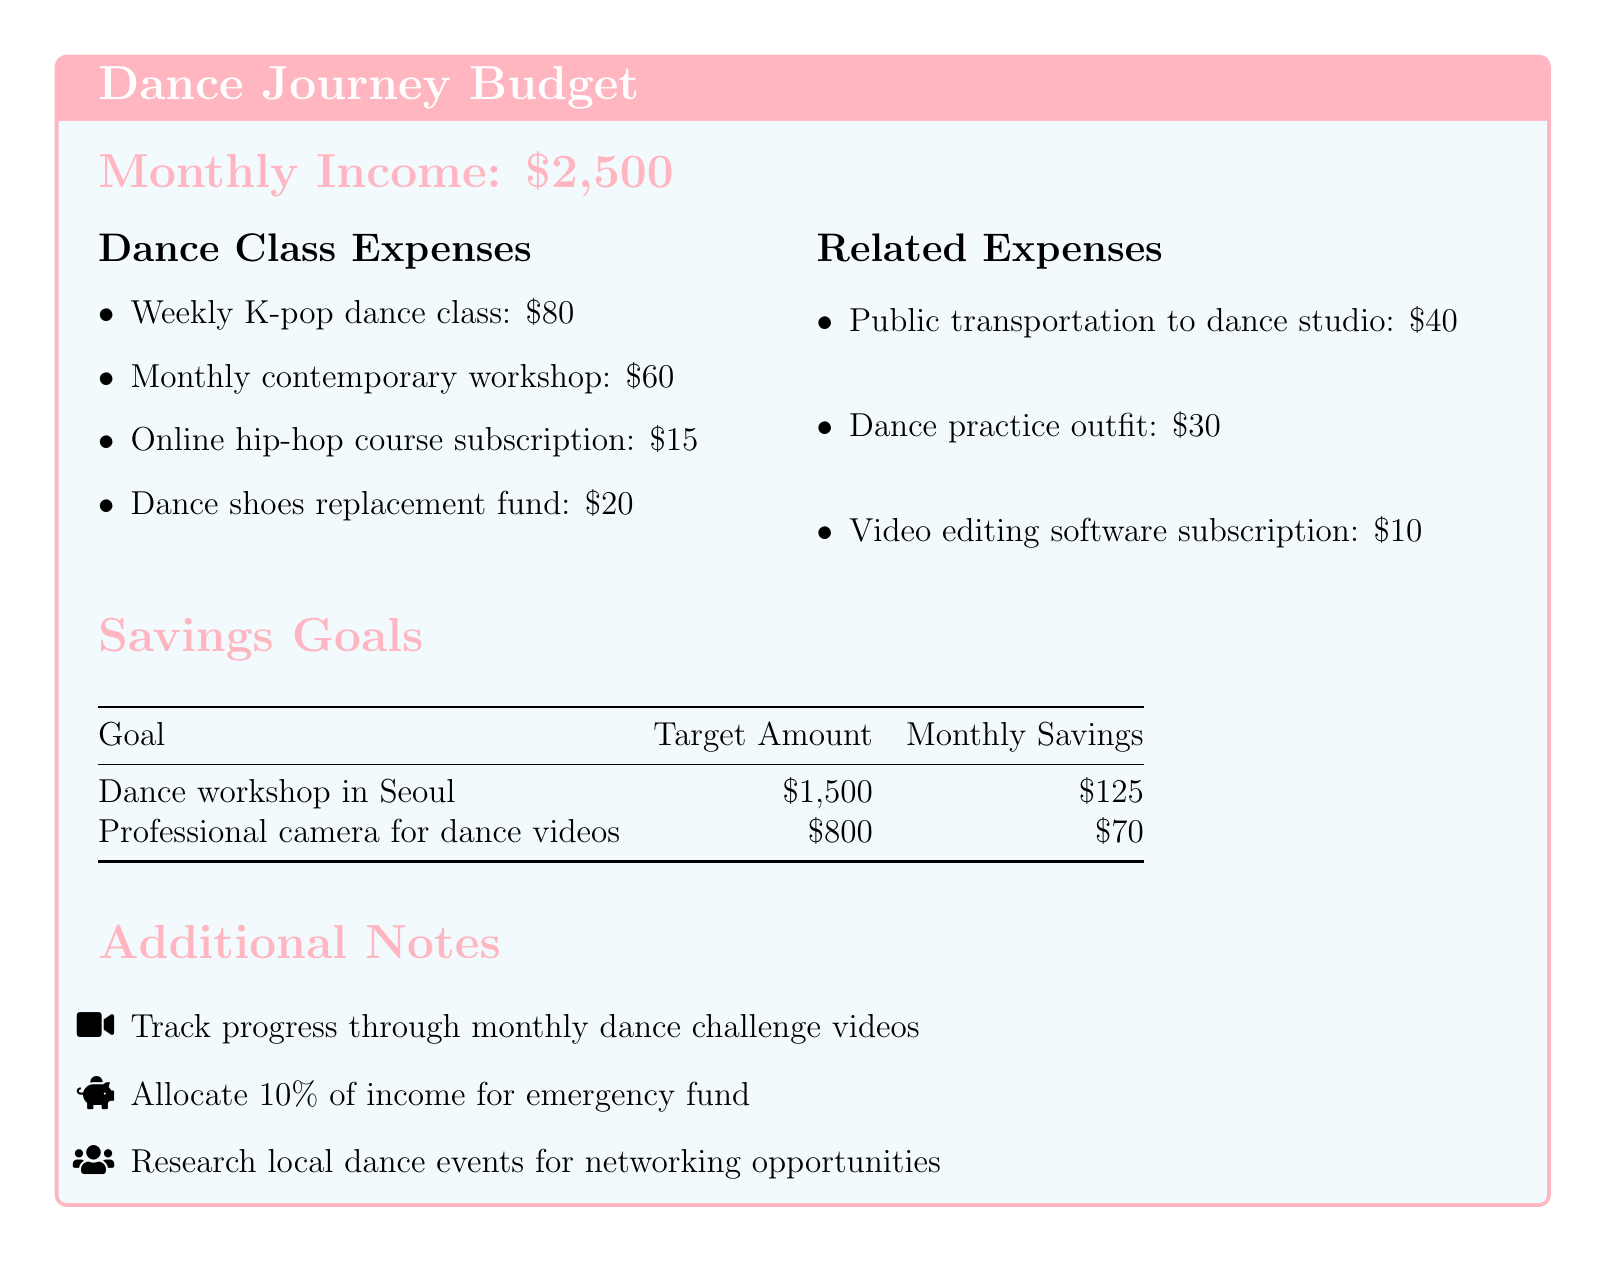What is the monthly income? The monthly income is stated at the beginning of the document.
Answer: $2,500 How much is the weekly K-pop dance class? The document lists the expense for the weekly K-pop dance class.
Answer: $80 What is the target amount for the professional camera? The target amount for this savings goal is specified in the table.
Answer: $800 How much is allocated monthly for the dance workshop in Seoul? The monthly savings for this goal is provided in the savings goals section.
Answer: $125 What is the total cost of related expenses? The document includes individual expenses, and adding them gives the total cost.
Answer: $80 How much do you need to save monthly for the professional camera? The monthly savings required for that goal can be found in the savings goals section.
Answer: $70 What percentage of income is suggested for the emergency fund? The document mentions this allocation as a note.
Answer: 10% How much is spent on public transportation to the dance studio? The public transportation expense is detailed in the related expenses section.
Answer: $40 What is the monthly cost for the online hip-hop course subscription? The document specifies this cost under dance class expenses.
Answer: $15 